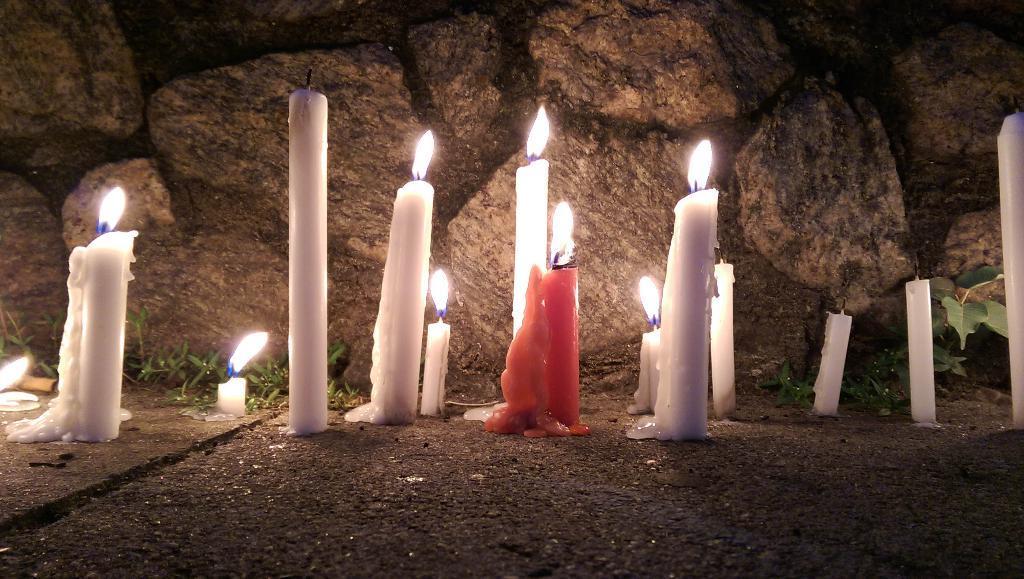Could you give a brief overview of what you see in this image? In the center of the image we can see candles. At the bottom there is a road. In the background there is a rock wall and we can see grass. 